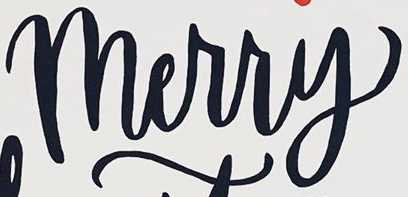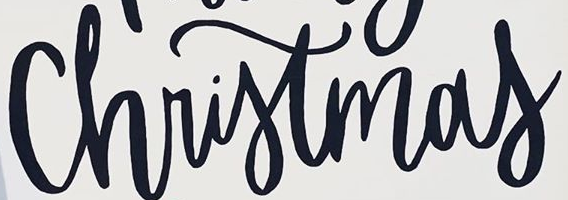Read the text from these images in sequence, separated by a semicolon. Merry; Christmas 